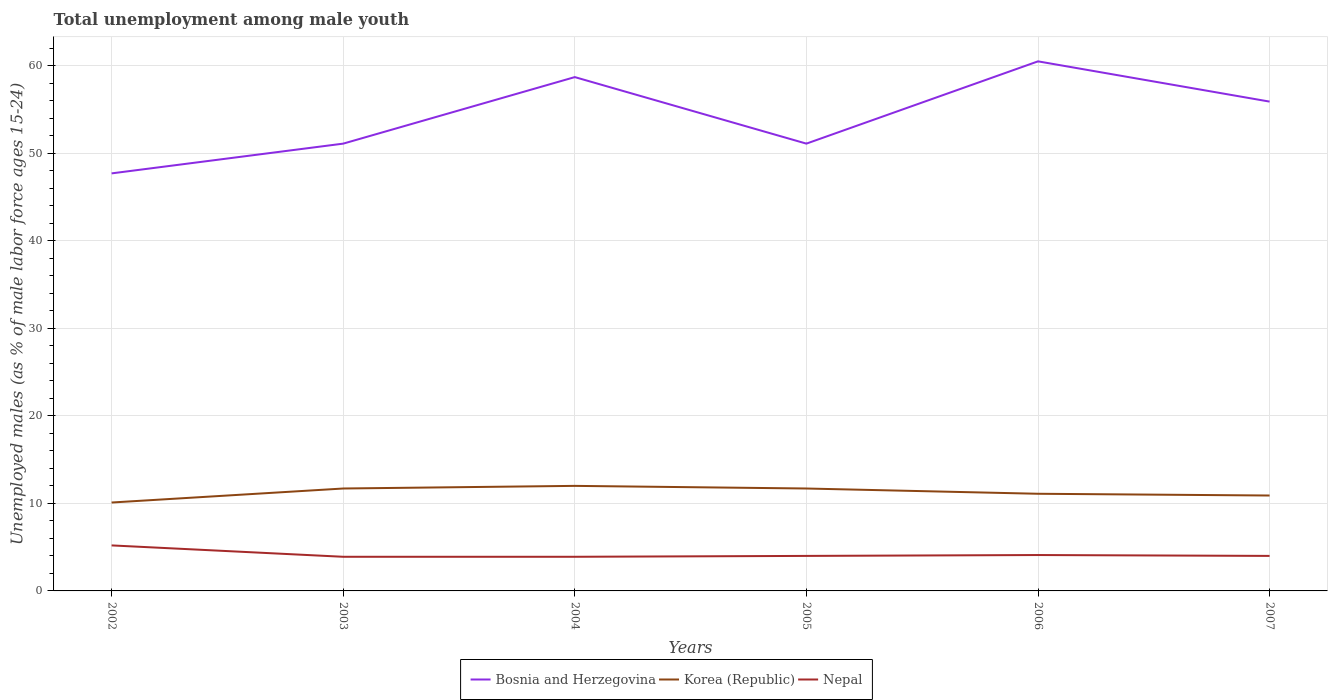Does the line corresponding to Bosnia and Herzegovina intersect with the line corresponding to Nepal?
Your answer should be compact. No. Is the number of lines equal to the number of legend labels?
Offer a terse response. Yes. Across all years, what is the maximum percentage of unemployed males in in Korea (Republic)?
Offer a very short reply. 10.1. What is the total percentage of unemployed males in in Bosnia and Herzegovina in the graph?
Make the answer very short. -1.8. What is the difference between the highest and the second highest percentage of unemployed males in in Bosnia and Herzegovina?
Keep it short and to the point. 12.8. Does the graph contain grids?
Keep it short and to the point. Yes. How many legend labels are there?
Your answer should be very brief. 3. How are the legend labels stacked?
Give a very brief answer. Horizontal. What is the title of the graph?
Your answer should be very brief. Total unemployment among male youth. Does "Iceland" appear as one of the legend labels in the graph?
Your answer should be very brief. No. What is the label or title of the X-axis?
Your answer should be compact. Years. What is the label or title of the Y-axis?
Offer a terse response. Unemployed males (as % of male labor force ages 15-24). What is the Unemployed males (as % of male labor force ages 15-24) of Bosnia and Herzegovina in 2002?
Ensure brevity in your answer.  47.7. What is the Unemployed males (as % of male labor force ages 15-24) of Korea (Republic) in 2002?
Ensure brevity in your answer.  10.1. What is the Unemployed males (as % of male labor force ages 15-24) of Nepal in 2002?
Keep it short and to the point. 5.2. What is the Unemployed males (as % of male labor force ages 15-24) of Bosnia and Herzegovina in 2003?
Keep it short and to the point. 51.1. What is the Unemployed males (as % of male labor force ages 15-24) in Korea (Republic) in 2003?
Provide a short and direct response. 11.7. What is the Unemployed males (as % of male labor force ages 15-24) of Nepal in 2003?
Keep it short and to the point. 3.9. What is the Unemployed males (as % of male labor force ages 15-24) in Bosnia and Herzegovina in 2004?
Provide a succinct answer. 58.7. What is the Unemployed males (as % of male labor force ages 15-24) of Nepal in 2004?
Ensure brevity in your answer.  3.9. What is the Unemployed males (as % of male labor force ages 15-24) of Bosnia and Herzegovina in 2005?
Give a very brief answer. 51.1. What is the Unemployed males (as % of male labor force ages 15-24) of Korea (Republic) in 2005?
Your response must be concise. 11.7. What is the Unemployed males (as % of male labor force ages 15-24) in Nepal in 2005?
Offer a very short reply. 4. What is the Unemployed males (as % of male labor force ages 15-24) in Bosnia and Herzegovina in 2006?
Provide a succinct answer. 60.5. What is the Unemployed males (as % of male labor force ages 15-24) in Korea (Republic) in 2006?
Offer a very short reply. 11.1. What is the Unemployed males (as % of male labor force ages 15-24) of Nepal in 2006?
Keep it short and to the point. 4.1. What is the Unemployed males (as % of male labor force ages 15-24) in Bosnia and Herzegovina in 2007?
Provide a short and direct response. 55.9. What is the Unemployed males (as % of male labor force ages 15-24) of Korea (Republic) in 2007?
Provide a succinct answer. 10.9. Across all years, what is the maximum Unemployed males (as % of male labor force ages 15-24) in Bosnia and Herzegovina?
Offer a terse response. 60.5. Across all years, what is the maximum Unemployed males (as % of male labor force ages 15-24) in Nepal?
Provide a succinct answer. 5.2. Across all years, what is the minimum Unemployed males (as % of male labor force ages 15-24) of Bosnia and Herzegovina?
Ensure brevity in your answer.  47.7. Across all years, what is the minimum Unemployed males (as % of male labor force ages 15-24) in Korea (Republic)?
Keep it short and to the point. 10.1. Across all years, what is the minimum Unemployed males (as % of male labor force ages 15-24) of Nepal?
Provide a short and direct response. 3.9. What is the total Unemployed males (as % of male labor force ages 15-24) of Bosnia and Herzegovina in the graph?
Offer a very short reply. 325. What is the total Unemployed males (as % of male labor force ages 15-24) of Korea (Republic) in the graph?
Make the answer very short. 67.5. What is the total Unemployed males (as % of male labor force ages 15-24) in Nepal in the graph?
Offer a very short reply. 25.1. What is the difference between the Unemployed males (as % of male labor force ages 15-24) in Nepal in 2002 and that in 2003?
Make the answer very short. 1.3. What is the difference between the Unemployed males (as % of male labor force ages 15-24) of Bosnia and Herzegovina in 2002 and that in 2004?
Provide a short and direct response. -11. What is the difference between the Unemployed males (as % of male labor force ages 15-24) in Korea (Republic) in 2002 and that in 2004?
Offer a very short reply. -1.9. What is the difference between the Unemployed males (as % of male labor force ages 15-24) of Nepal in 2002 and that in 2005?
Your answer should be very brief. 1.2. What is the difference between the Unemployed males (as % of male labor force ages 15-24) of Korea (Republic) in 2002 and that in 2006?
Ensure brevity in your answer.  -1. What is the difference between the Unemployed males (as % of male labor force ages 15-24) in Bosnia and Herzegovina in 2002 and that in 2007?
Keep it short and to the point. -8.2. What is the difference between the Unemployed males (as % of male labor force ages 15-24) in Bosnia and Herzegovina in 2003 and that in 2004?
Make the answer very short. -7.6. What is the difference between the Unemployed males (as % of male labor force ages 15-24) in Nepal in 2003 and that in 2004?
Your answer should be very brief. 0. What is the difference between the Unemployed males (as % of male labor force ages 15-24) in Nepal in 2003 and that in 2005?
Keep it short and to the point. -0.1. What is the difference between the Unemployed males (as % of male labor force ages 15-24) in Bosnia and Herzegovina in 2003 and that in 2006?
Give a very brief answer. -9.4. What is the difference between the Unemployed males (as % of male labor force ages 15-24) of Bosnia and Herzegovina in 2003 and that in 2007?
Give a very brief answer. -4.8. What is the difference between the Unemployed males (as % of male labor force ages 15-24) of Nepal in 2003 and that in 2007?
Your answer should be compact. -0.1. What is the difference between the Unemployed males (as % of male labor force ages 15-24) of Korea (Republic) in 2004 and that in 2005?
Offer a very short reply. 0.3. What is the difference between the Unemployed males (as % of male labor force ages 15-24) of Nepal in 2004 and that in 2005?
Make the answer very short. -0.1. What is the difference between the Unemployed males (as % of male labor force ages 15-24) of Bosnia and Herzegovina in 2004 and that in 2006?
Give a very brief answer. -1.8. What is the difference between the Unemployed males (as % of male labor force ages 15-24) of Nepal in 2004 and that in 2006?
Give a very brief answer. -0.2. What is the difference between the Unemployed males (as % of male labor force ages 15-24) of Korea (Republic) in 2004 and that in 2007?
Your answer should be compact. 1.1. What is the difference between the Unemployed males (as % of male labor force ages 15-24) of Nepal in 2004 and that in 2007?
Offer a terse response. -0.1. What is the difference between the Unemployed males (as % of male labor force ages 15-24) of Korea (Republic) in 2005 and that in 2006?
Your answer should be compact. 0.6. What is the difference between the Unemployed males (as % of male labor force ages 15-24) in Korea (Republic) in 2005 and that in 2007?
Provide a succinct answer. 0.8. What is the difference between the Unemployed males (as % of male labor force ages 15-24) in Nepal in 2005 and that in 2007?
Keep it short and to the point. 0. What is the difference between the Unemployed males (as % of male labor force ages 15-24) of Korea (Republic) in 2006 and that in 2007?
Keep it short and to the point. 0.2. What is the difference between the Unemployed males (as % of male labor force ages 15-24) of Nepal in 2006 and that in 2007?
Provide a short and direct response. 0.1. What is the difference between the Unemployed males (as % of male labor force ages 15-24) of Bosnia and Herzegovina in 2002 and the Unemployed males (as % of male labor force ages 15-24) of Korea (Republic) in 2003?
Make the answer very short. 36. What is the difference between the Unemployed males (as % of male labor force ages 15-24) of Bosnia and Herzegovina in 2002 and the Unemployed males (as % of male labor force ages 15-24) of Nepal in 2003?
Offer a very short reply. 43.8. What is the difference between the Unemployed males (as % of male labor force ages 15-24) in Korea (Republic) in 2002 and the Unemployed males (as % of male labor force ages 15-24) in Nepal in 2003?
Make the answer very short. 6.2. What is the difference between the Unemployed males (as % of male labor force ages 15-24) in Bosnia and Herzegovina in 2002 and the Unemployed males (as % of male labor force ages 15-24) in Korea (Republic) in 2004?
Provide a succinct answer. 35.7. What is the difference between the Unemployed males (as % of male labor force ages 15-24) of Bosnia and Herzegovina in 2002 and the Unemployed males (as % of male labor force ages 15-24) of Nepal in 2004?
Your response must be concise. 43.8. What is the difference between the Unemployed males (as % of male labor force ages 15-24) of Korea (Republic) in 2002 and the Unemployed males (as % of male labor force ages 15-24) of Nepal in 2004?
Your response must be concise. 6.2. What is the difference between the Unemployed males (as % of male labor force ages 15-24) in Bosnia and Herzegovina in 2002 and the Unemployed males (as % of male labor force ages 15-24) in Korea (Republic) in 2005?
Offer a very short reply. 36. What is the difference between the Unemployed males (as % of male labor force ages 15-24) of Bosnia and Herzegovina in 2002 and the Unemployed males (as % of male labor force ages 15-24) of Nepal in 2005?
Make the answer very short. 43.7. What is the difference between the Unemployed males (as % of male labor force ages 15-24) in Bosnia and Herzegovina in 2002 and the Unemployed males (as % of male labor force ages 15-24) in Korea (Republic) in 2006?
Your response must be concise. 36.6. What is the difference between the Unemployed males (as % of male labor force ages 15-24) of Bosnia and Herzegovina in 2002 and the Unemployed males (as % of male labor force ages 15-24) of Nepal in 2006?
Provide a short and direct response. 43.6. What is the difference between the Unemployed males (as % of male labor force ages 15-24) in Korea (Republic) in 2002 and the Unemployed males (as % of male labor force ages 15-24) in Nepal in 2006?
Give a very brief answer. 6. What is the difference between the Unemployed males (as % of male labor force ages 15-24) in Bosnia and Herzegovina in 2002 and the Unemployed males (as % of male labor force ages 15-24) in Korea (Republic) in 2007?
Provide a succinct answer. 36.8. What is the difference between the Unemployed males (as % of male labor force ages 15-24) of Bosnia and Herzegovina in 2002 and the Unemployed males (as % of male labor force ages 15-24) of Nepal in 2007?
Your response must be concise. 43.7. What is the difference between the Unemployed males (as % of male labor force ages 15-24) of Korea (Republic) in 2002 and the Unemployed males (as % of male labor force ages 15-24) of Nepal in 2007?
Keep it short and to the point. 6.1. What is the difference between the Unemployed males (as % of male labor force ages 15-24) of Bosnia and Herzegovina in 2003 and the Unemployed males (as % of male labor force ages 15-24) of Korea (Republic) in 2004?
Provide a succinct answer. 39.1. What is the difference between the Unemployed males (as % of male labor force ages 15-24) of Bosnia and Herzegovina in 2003 and the Unemployed males (as % of male labor force ages 15-24) of Nepal in 2004?
Provide a succinct answer. 47.2. What is the difference between the Unemployed males (as % of male labor force ages 15-24) in Bosnia and Herzegovina in 2003 and the Unemployed males (as % of male labor force ages 15-24) in Korea (Republic) in 2005?
Offer a very short reply. 39.4. What is the difference between the Unemployed males (as % of male labor force ages 15-24) of Bosnia and Herzegovina in 2003 and the Unemployed males (as % of male labor force ages 15-24) of Nepal in 2005?
Your answer should be compact. 47.1. What is the difference between the Unemployed males (as % of male labor force ages 15-24) in Bosnia and Herzegovina in 2003 and the Unemployed males (as % of male labor force ages 15-24) in Nepal in 2006?
Give a very brief answer. 47. What is the difference between the Unemployed males (as % of male labor force ages 15-24) in Bosnia and Herzegovina in 2003 and the Unemployed males (as % of male labor force ages 15-24) in Korea (Republic) in 2007?
Keep it short and to the point. 40.2. What is the difference between the Unemployed males (as % of male labor force ages 15-24) of Bosnia and Herzegovina in 2003 and the Unemployed males (as % of male labor force ages 15-24) of Nepal in 2007?
Provide a succinct answer. 47.1. What is the difference between the Unemployed males (as % of male labor force ages 15-24) in Korea (Republic) in 2003 and the Unemployed males (as % of male labor force ages 15-24) in Nepal in 2007?
Provide a short and direct response. 7.7. What is the difference between the Unemployed males (as % of male labor force ages 15-24) in Bosnia and Herzegovina in 2004 and the Unemployed males (as % of male labor force ages 15-24) in Nepal in 2005?
Your response must be concise. 54.7. What is the difference between the Unemployed males (as % of male labor force ages 15-24) in Bosnia and Herzegovina in 2004 and the Unemployed males (as % of male labor force ages 15-24) in Korea (Republic) in 2006?
Keep it short and to the point. 47.6. What is the difference between the Unemployed males (as % of male labor force ages 15-24) in Bosnia and Herzegovina in 2004 and the Unemployed males (as % of male labor force ages 15-24) in Nepal in 2006?
Your answer should be very brief. 54.6. What is the difference between the Unemployed males (as % of male labor force ages 15-24) of Korea (Republic) in 2004 and the Unemployed males (as % of male labor force ages 15-24) of Nepal in 2006?
Make the answer very short. 7.9. What is the difference between the Unemployed males (as % of male labor force ages 15-24) in Bosnia and Herzegovina in 2004 and the Unemployed males (as % of male labor force ages 15-24) in Korea (Republic) in 2007?
Keep it short and to the point. 47.8. What is the difference between the Unemployed males (as % of male labor force ages 15-24) in Bosnia and Herzegovina in 2004 and the Unemployed males (as % of male labor force ages 15-24) in Nepal in 2007?
Ensure brevity in your answer.  54.7. What is the difference between the Unemployed males (as % of male labor force ages 15-24) in Bosnia and Herzegovina in 2005 and the Unemployed males (as % of male labor force ages 15-24) in Nepal in 2006?
Provide a succinct answer. 47. What is the difference between the Unemployed males (as % of male labor force ages 15-24) of Korea (Republic) in 2005 and the Unemployed males (as % of male labor force ages 15-24) of Nepal in 2006?
Make the answer very short. 7.6. What is the difference between the Unemployed males (as % of male labor force ages 15-24) of Bosnia and Herzegovina in 2005 and the Unemployed males (as % of male labor force ages 15-24) of Korea (Republic) in 2007?
Give a very brief answer. 40.2. What is the difference between the Unemployed males (as % of male labor force ages 15-24) of Bosnia and Herzegovina in 2005 and the Unemployed males (as % of male labor force ages 15-24) of Nepal in 2007?
Your answer should be very brief. 47.1. What is the difference between the Unemployed males (as % of male labor force ages 15-24) in Bosnia and Herzegovina in 2006 and the Unemployed males (as % of male labor force ages 15-24) in Korea (Republic) in 2007?
Your response must be concise. 49.6. What is the difference between the Unemployed males (as % of male labor force ages 15-24) of Bosnia and Herzegovina in 2006 and the Unemployed males (as % of male labor force ages 15-24) of Nepal in 2007?
Keep it short and to the point. 56.5. What is the average Unemployed males (as % of male labor force ages 15-24) in Bosnia and Herzegovina per year?
Offer a very short reply. 54.17. What is the average Unemployed males (as % of male labor force ages 15-24) of Korea (Republic) per year?
Ensure brevity in your answer.  11.25. What is the average Unemployed males (as % of male labor force ages 15-24) of Nepal per year?
Make the answer very short. 4.18. In the year 2002, what is the difference between the Unemployed males (as % of male labor force ages 15-24) in Bosnia and Herzegovina and Unemployed males (as % of male labor force ages 15-24) in Korea (Republic)?
Your answer should be very brief. 37.6. In the year 2002, what is the difference between the Unemployed males (as % of male labor force ages 15-24) of Bosnia and Herzegovina and Unemployed males (as % of male labor force ages 15-24) of Nepal?
Keep it short and to the point. 42.5. In the year 2002, what is the difference between the Unemployed males (as % of male labor force ages 15-24) in Korea (Republic) and Unemployed males (as % of male labor force ages 15-24) in Nepal?
Make the answer very short. 4.9. In the year 2003, what is the difference between the Unemployed males (as % of male labor force ages 15-24) of Bosnia and Herzegovina and Unemployed males (as % of male labor force ages 15-24) of Korea (Republic)?
Keep it short and to the point. 39.4. In the year 2003, what is the difference between the Unemployed males (as % of male labor force ages 15-24) of Bosnia and Herzegovina and Unemployed males (as % of male labor force ages 15-24) of Nepal?
Offer a terse response. 47.2. In the year 2004, what is the difference between the Unemployed males (as % of male labor force ages 15-24) of Bosnia and Herzegovina and Unemployed males (as % of male labor force ages 15-24) of Korea (Republic)?
Give a very brief answer. 46.7. In the year 2004, what is the difference between the Unemployed males (as % of male labor force ages 15-24) in Bosnia and Herzegovina and Unemployed males (as % of male labor force ages 15-24) in Nepal?
Keep it short and to the point. 54.8. In the year 2005, what is the difference between the Unemployed males (as % of male labor force ages 15-24) in Bosnia and Herzegovina and Unemployed males (as % of male labor force ages 15-24) in Korea (Republic)?
Your response must be concise. 39.4. In the year 2005, what is the difference between the Unemployed males (as % of male labor force ages 15-24) of Bosnia and Herzegovina and Unemployed males (as % of male labor force ages 15-24) of Nepal?
Your response must be concise. 47.1. In the year 2006, what is the difference between the Unemployed males (as % of male labor force ages 15-24) in Bosnia and Herzegovina and Unemployed males (as % of male labor force ages 15-24) in Korea (Republic)?
Keep it short and to the point. 49.4. In the year 2006, what is the difference between the Unemployed males (as % of male labor force ages 15-24) in Bosnia and Herzegovina and Unemployed males (as % of male labor force ages 15-24) in Nepal?
Your answer should be very brief. 56.4. In the year 2007, what is the difference between the Unemployed males (as % of male labor force ages 15-24) in Bosnia and Herzegovina and Unemployed males (as % of male labor force ages 15-24) in Korea (Republic)?
Give a very brief answer. 45. In the year 2007, what is the difference between the Unemployed males (as % of male labor force ages 15-24) of Bosnia and Herzegovina and Unemployed males (as % of male labor force ages 15-24) of Nepal?
Your answer should be compact. 51.9. In the year 2007, what is the difference between the Unemployed males (as % of male labor force ages 15-24) of Korea (Republic) and Unemployed males (as % of male labor force ages 15-24) of Nepal?
Provide a short and direct response. 6.9. What is the ratio of the Unemployed males (as % of male labor force ages 15-24) of Bosnia and Herzegovina in 2002 to that in 2003?
Your answer should be compact. 0.93. What is the ratio of the Unemployed males (as % of male labor force ages 15-24) in Korea (Republic) in 2002 to that in 2003?
Give a very brief answer. 0.86. What is the ratio of the Unemployed males (as % of male labor force ages 15-24) of Bosnia and Herzegovina in 2002 to that in 2004?
Offer a terse response. 0.81. What is the ratio of the Unemployed males (as % of male labor force ages 15-24) of Korea (Republic) in 2002 to that in 2004?
Ensure brevity in your answer.  0.84. What is the ratio of the Unemployed males (as % of male labor force ages 15-24) of Bosnia and Herzegovina in 2002 to that in 2005?
Ensure brevity in your answer.  0.93. What is the ratio of the Unemployed males (as % of male labor force ages 15-24) in Korea (Republic) in 2002 to that in 2005?
Your answer should be compact. 0.86. What is the ratio of the Unemployed males (as % of male labor force ages 15-24) in Bosnia and Herzegovina in 2002 to that in 2006?
Offer a terse response. 0.79. What is the ratio of the Unemployed males (as % of male labor force ages 15-24) of Korea (Republic) in 2002 to that in 2006?
Offer a terse response. 0.91. What is the ratio of the Unemployed males (as % of male labor force ages 15-24) in Nepal in 2002 to that in 2006?
Your answer should be compact. 1.27. What is the ratio of the Unemployed males (as % of male labor force ages 15-24) of Bosnia and Herzegovina in 2002 to that in 2007?
Your response must be concise. 0.85. What is the ratio of the Unemployed males (as % of male labor force ages 15-24) of Korea (Republic) in 2002 to that in 2007?
Give a very brief answer. 0.93. What is the ratio of the Unemployed males (as % of male labor force ages 15-24) in Bosnia and Herzegovina in 2003 to that in 2004?
Keep it short and to the point. 0.87. What is the ratio of the Unemployed males (as % of male labor force ages 15-24) of Korea (Republic) in 2003 to that in 2004?
Keep it short and to the point. 0.97. What is the ratio of the Unemployed males (as % of male labor force ages 15-24) of Bosnia and Herzegovina in 2003 to that in 2006?
Provide a short and direct response. 0.84. What is the ratio of the Unemployed males (as % of male labor force ages 15-24) in Korea (Republic) in 2003 to that in 2006?
Your response must be concise. 1.05. What is the ratio of the Unemployed males (as % of male labor force ages 15-24) of Nepal in 2003 to that in 2006?
Ensure brevity in your answer.  0.95. What is the ratio of the Unemployed males (as % of male labor force ages 15-24) of Bosnia and Herzegovina in 2003 to that in 2007?
Make the answer very short. 0.91. What is the ratio of the Unemployed males (as % of male labor force ages 15-24) of Korea (Republic) in 2003 to that in 2007?
Give a very brief answer. 1.07. What is the ratio of the Unemployed males (as % of male labor force ages 15-24) in Bosnia and Herzegovina in 2004 to that in 2005?
Provide a succinct answer. 1.15. What is the ratio of the Unemployed males (as % of male labor force ages 15-24) of Korea (Republic) in 2004 to that in 2005?
Make the answer very short. 1.03. What is the ratio of the Unemployed males (as % of male labor force ages 15-24) of Nepal in 2004 to that in 2005?
Ensure brevity in your answer.  0.97. What is the ratio of the Unemployed males (as % of male labor force ages 15-24) in Bosnia and Herzegovina in 2004 to that in 2006?
Give a very brief answer. 0.97. What is the ratio of the Unemployed males (as % of male labor force ages 15-24) in Korea (Republic) in 2004 to that in 2006?
Your answer should be compact. 1.08. What is the ratio of the Unemployed males (as % of male labor force ages 15-24) in Nepal in 2004 to that in 2006?
Keep it short and to the point. 0.95. What is the ratio of the Unemployed males (as % of male labor force ages 15-24) of Bosnia and Herzegovina in 2004 to that in 2007?
Offer a very short reply. 1.05. What is the ratio of the Unemployed males (as % of male labor force ages 15-24) in Korea (Republic) in 2004 to that in 2007?
Offer a very short reply. 1.1. What is the ratio of the Unemployed males (as % of male labor force ages 15-24) of Bosnia and Herzegovina in 2005 to that in 2006?
Your answer should be very brief. 0.84. What is the ratio of the Unemployed males (as % of male labor force ages 15-24) in Korea (Republic) in 2005 to that in 2006?
Your response must be concise. 1.05. What is the ratio of the Unemployed males (as % of male labor force ages 15-24) in Nepal in 2005 to that in 2006?
Your answer should be very brief. 0.98. What is the ratio of the Unemployed males (as % of male labor force ages 15-24) of Bosnia and Herzegovina in 2005 to that in 2007?
Your response must be concise. 0.91. What is the ratio of the Unemployed males (as % of male labor force ages 15-24) in Korea (Republic) in 2005 to that in 2007?
Give a very brief answer. 1.07. What is the ratio of the Unemployed males (as % of male labor force ages 15-24) in Nepal in 2005 to that in 2007?
Give a very brief answer. 1. What is the ratio of the Unemployed males (as % of male labor force ages 15-24) in Bosnia and Herzegovina in 2006 to that in 2007?
Offer a terse response. 1.08. What is the ratio of the Unemployed males (as % of male labor force ages 15-24) of Korea (Republic) in 2006 to that in 2007?
Provide a succinct answer. 1.02. What is the ratio of the Unemployed males (as % of male labor force ages 15-24) in Nepal in 2006 to that in 2007?
Provide a short and direct response. 1.02. What is the difference between the highest and the second highest Unemployed males (as % of male labor force ages 15-24) in Korea (Republic)?
Keep it short and to the point. 0.3. What is the difference between the highest and the second highest Unemployed males (as % of male labor force ages 15-24) in Nepal?
Offer a very short reply. 1.1. What is the difference between the highest and the lowest Unemployed males (as % of male labor force ages 15-24) of Nepal?
Make the answer very short. 1.3. 